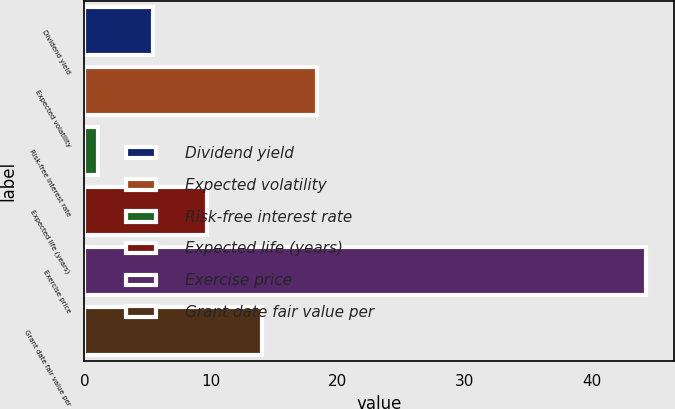Convert chart. <chart><loc_0><loc_0><loc_500><loc_500><bar_chart><fcel>Dividend yield<fcel>Expected volatility<fcel>Risk-free interest rate<fcel>Expected life (years)<fcel>Exercise price<fcel>Grant date fair value per<nl><fcel>5.38<fcel>18.34<fcel>1.06<fcel>9.7<fcel>44.29<fcel>14.02<nl></chart> 